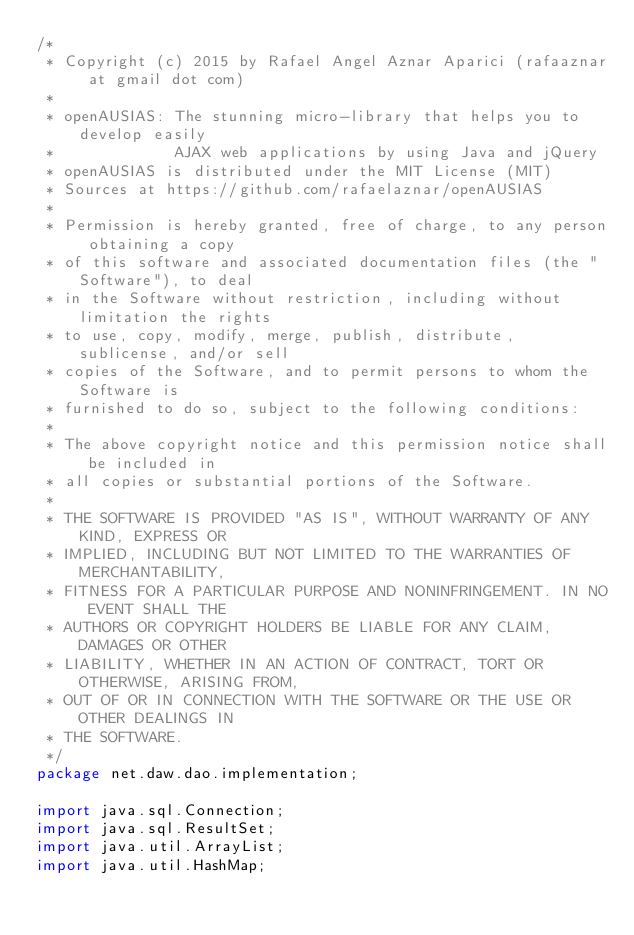<code> <loc_0><loc_0><loc_500><loc_500><_Java_>/*
 * Copyright (c) 2015 by Rafael Angel Aznar Aparici (rafaaznar at gmail dot com)
 * 
 * openAUSIAS: The stunning micro-library that helps you to develop easily 
 *             AJAX web applications by using Java and jQuery
 * openAUSIAS is distributed under the MIT License (MIT)
 * Sources at https://github.com/rafaelaznar/openAUSIAS
 * 
 * Permission is hereby granted, free of charge, to any person obtaining a copy
 * of this software and associated documentation files (the "Software"), to deal
 * in the Software without restriction, including without limitation the rights
 * to use, copy, modify, merge, publish, distribute, sublicense, and/or sell
 * copies of the Software, and to permit persons to whom the Software is
 * furnished to do so, subject to the following conditions:
 * 
 * The above copyright notice and this permission notice shall be included in
 * all copies or substantial portions of the Software.
 * 
 * THE SOFTWARE IS PROVIDED "AS IS", WITHOUT WARRANTY OF ANY KIND, EXPRESS OR
 * IMPLIED, INCLUDING BUT NOT LIMITED TO THE WARRANTIES OF MERCHANTABILITY,
 * FITNESS FOR A PARTICULAR PURPOSE AND NONINFRINGEMENT. IN NO EVENT SHALL THE
 * AUTHORS OR COPYRIGHT HOLDERS BE LIABLE FOR ANY CLAIM, DAMAGES OR OTHER
 * LIABILITY, WHETHER IN AN ACTION OF CONTRACT, TORT OR OTHERWISE, ARISING FROM,
 * OUT OF OR IN CONNECTION WITH THE SOFTWARE OR THE USE OR OTHER DEALINGS IN
 * THE SOFTWARE.
 */
package net.daw.dao.implementation;

import java.sql.Connection;
import java.sql.ResultSet;
import java.util.ArrayList;
import java.util.HashMap;</code> 